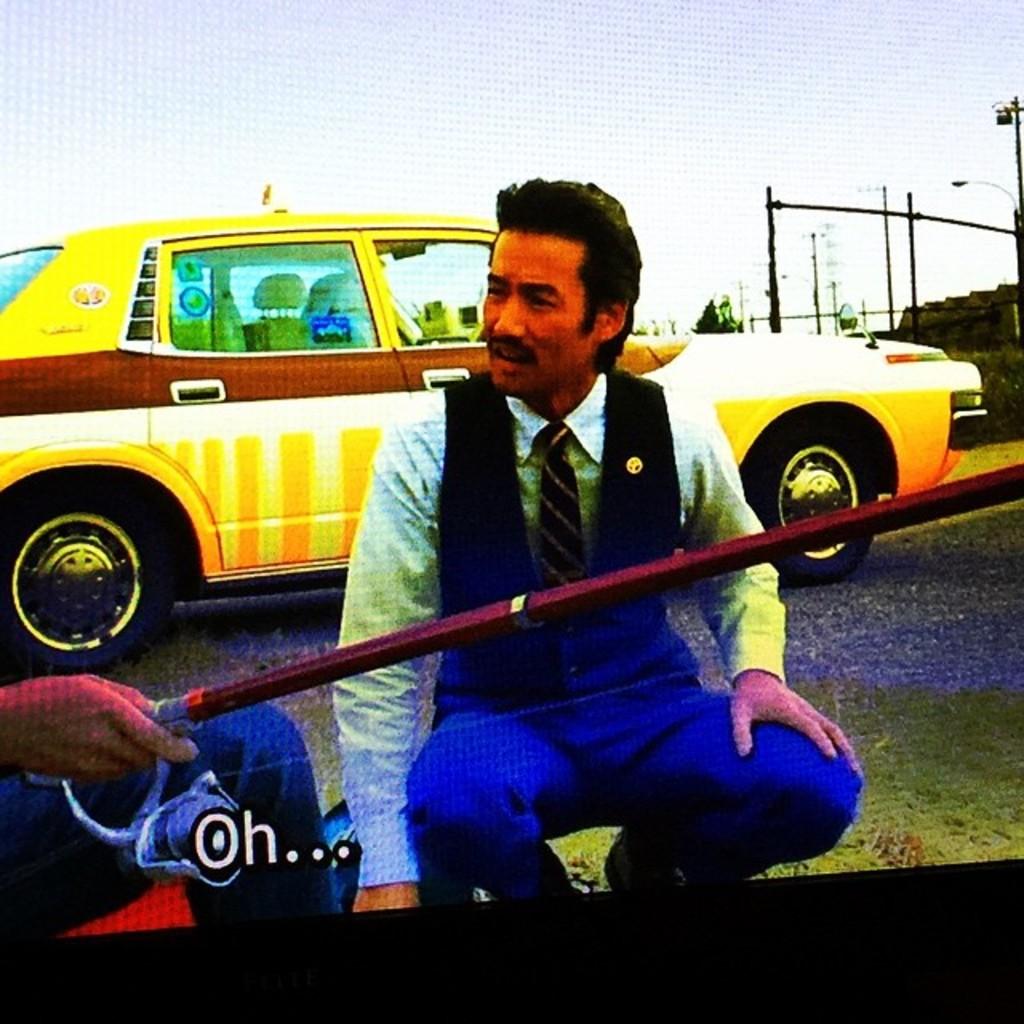What is the guy saying?
Your response must be concise. Oh... How many periods appear after oh?
Your answer should be very brief. 3. 